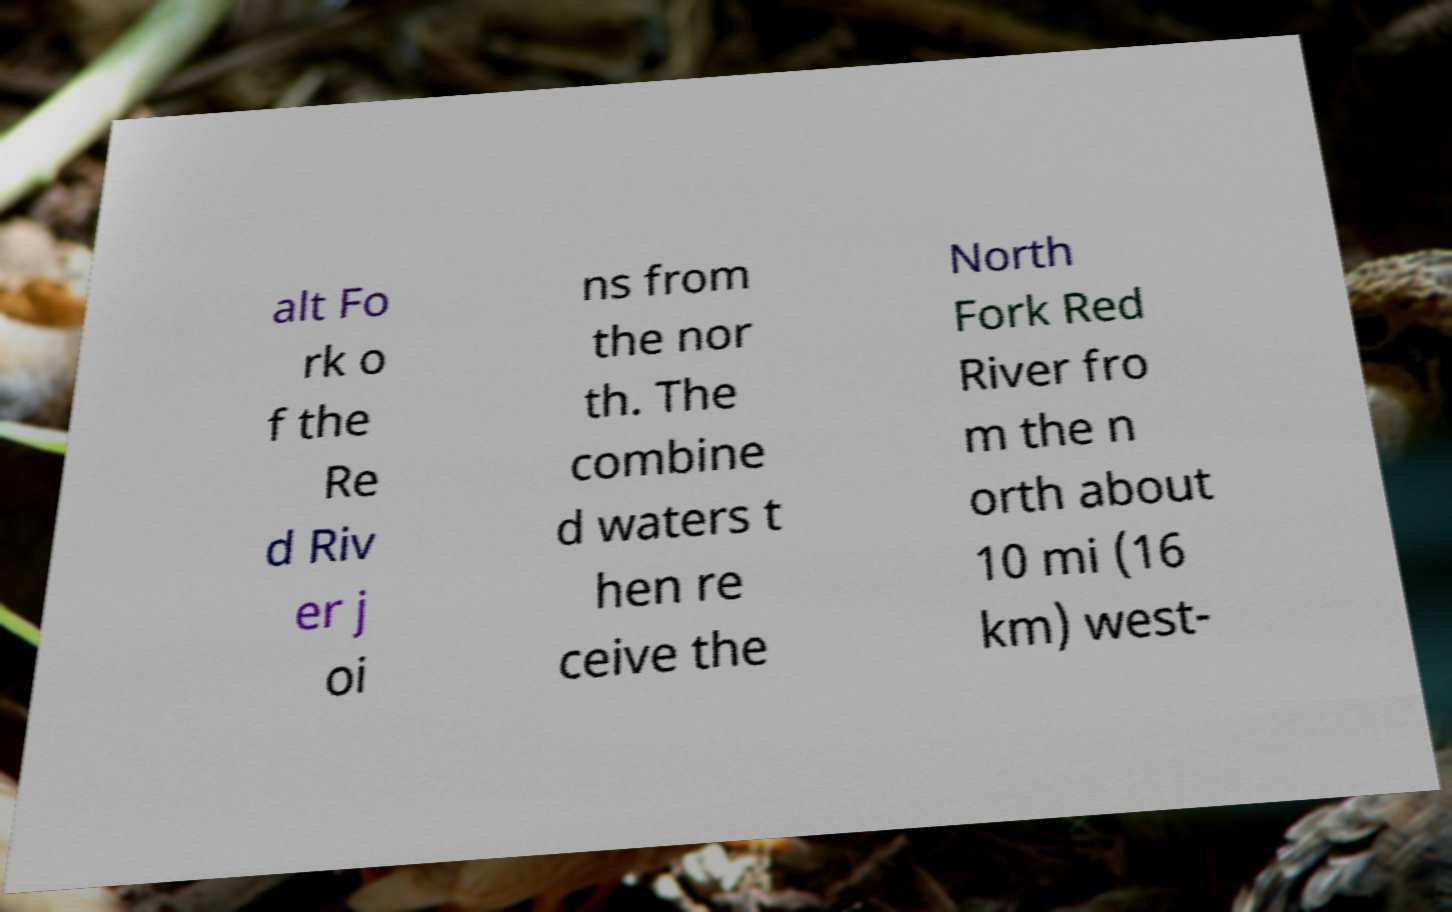What messages or text are displayed in this image? I need them in a readable, typed format. alt Fo rk o f the Re d Riv er j oi ns from the nor th. The combine d waters t hen re ceive the North Fork Red River fro m the n orth about 10 mi (16 km) west- 